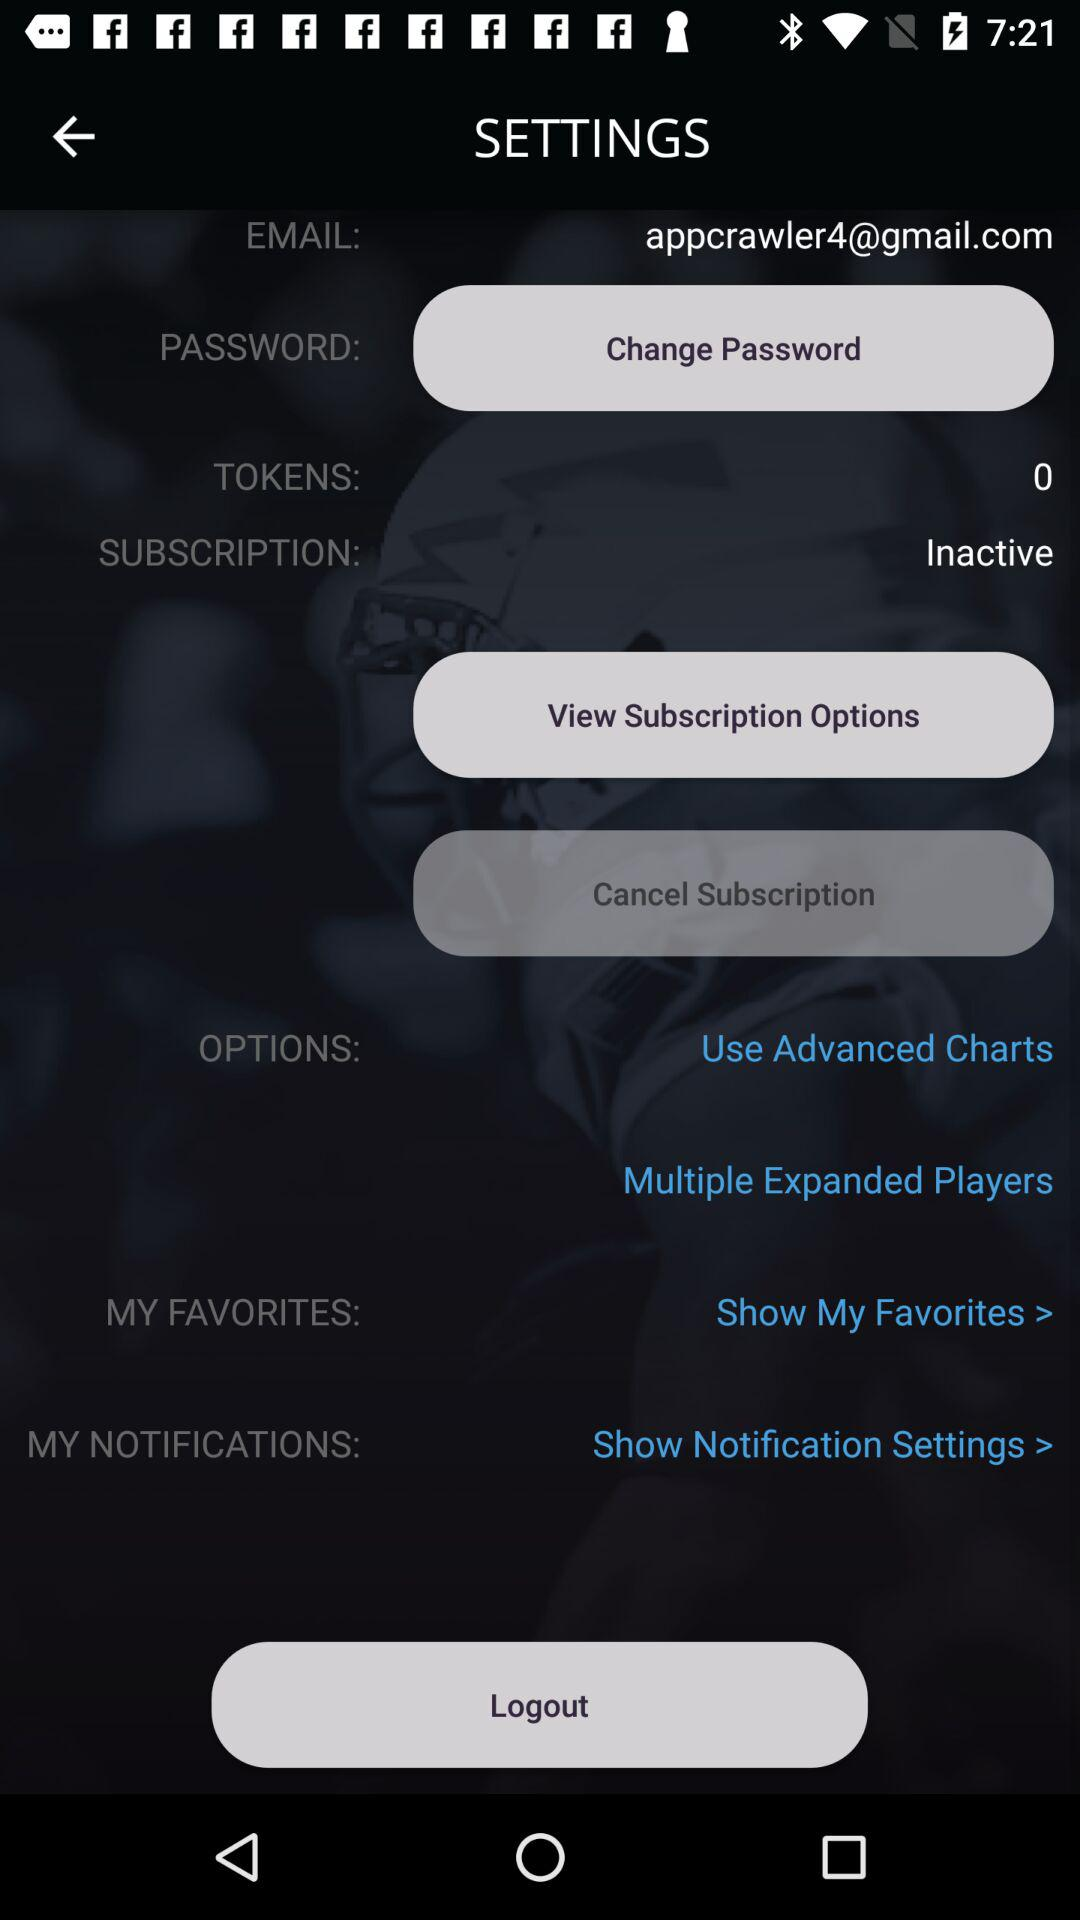How many more tokens do I have than subscriptions?
Answer the question using a single word or phrase. 0 